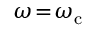Convert formula to latex. <formula><loc_0><loc_0><loc_500><loc_500>\omega \, = \, \omega _ { c }</formula> 